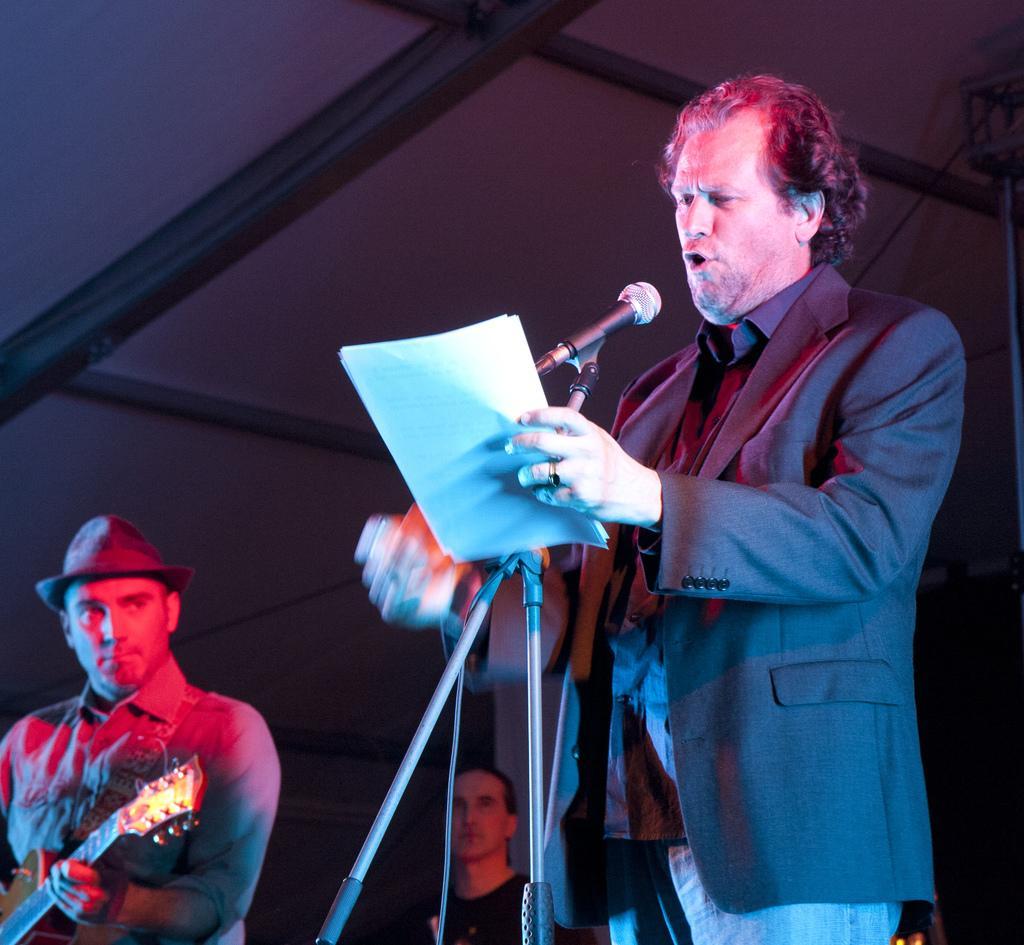Please provide a concise description of this image. In this picture we can see a man standing in front of a mike holding paper in his and singing. At the left side of the picture we can see one man wearing a hat and playing a guitar. Behind to this man we can see other person. 